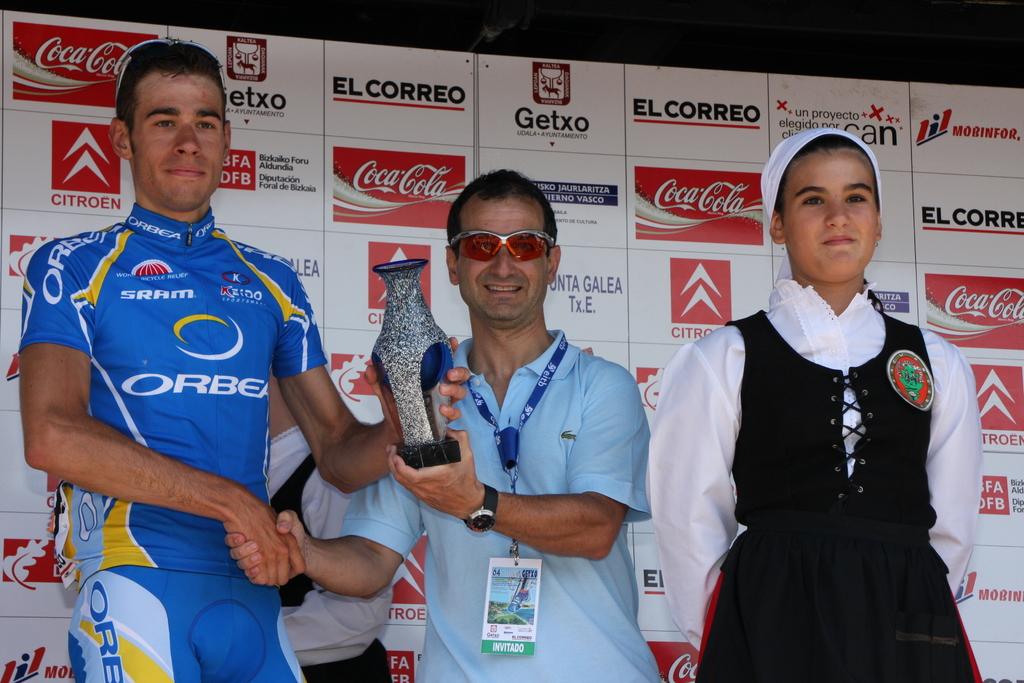What beverage has a logo on the wall behind the people?
Provide a succinct answer. Coca-cola. Whats the company on pinned wall?
Give a very brief answer. Coca cola. 